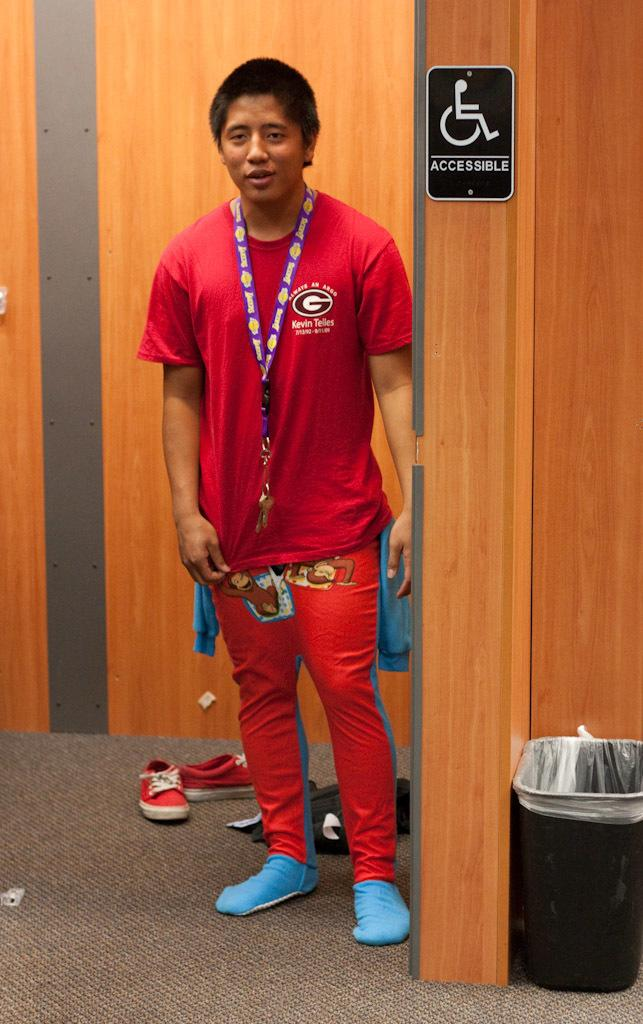<image>
Offer a succinct explanation of the picture presented. a boy standing next to an accessible sign on the door 